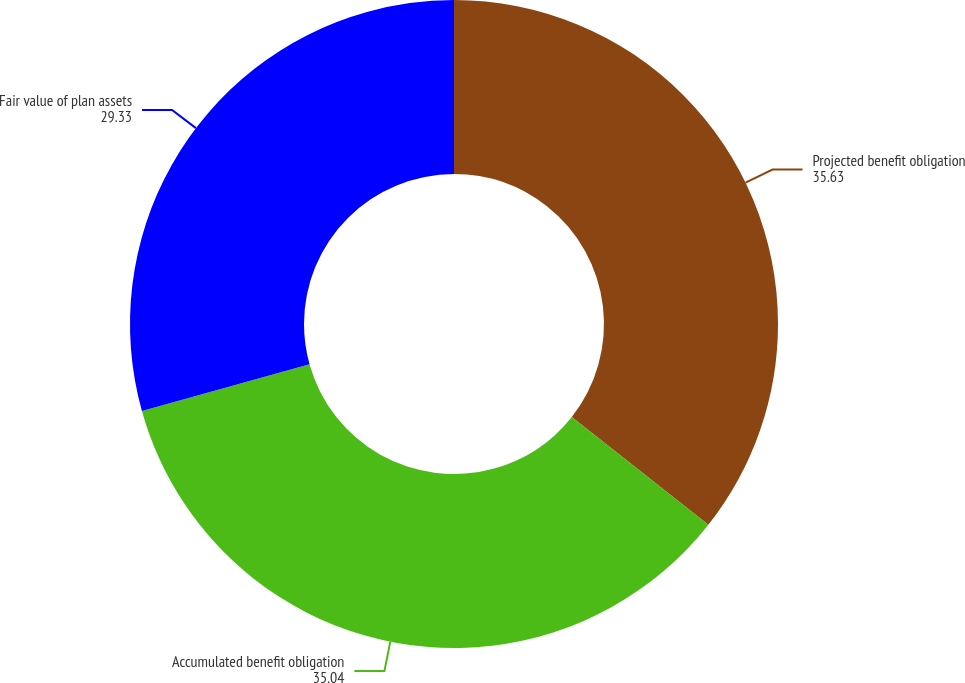Convert chart. <chart><loc_0><loc_0><loc_500><loc_500><pie_chart><fcel>Projected benefit obligation<fcel>Accumulated benefit obligation<fcel>Fair value of plan assets<nl><fcel>35.63%<fcel>35.04%<fcel>29.33%<nl></chart> 